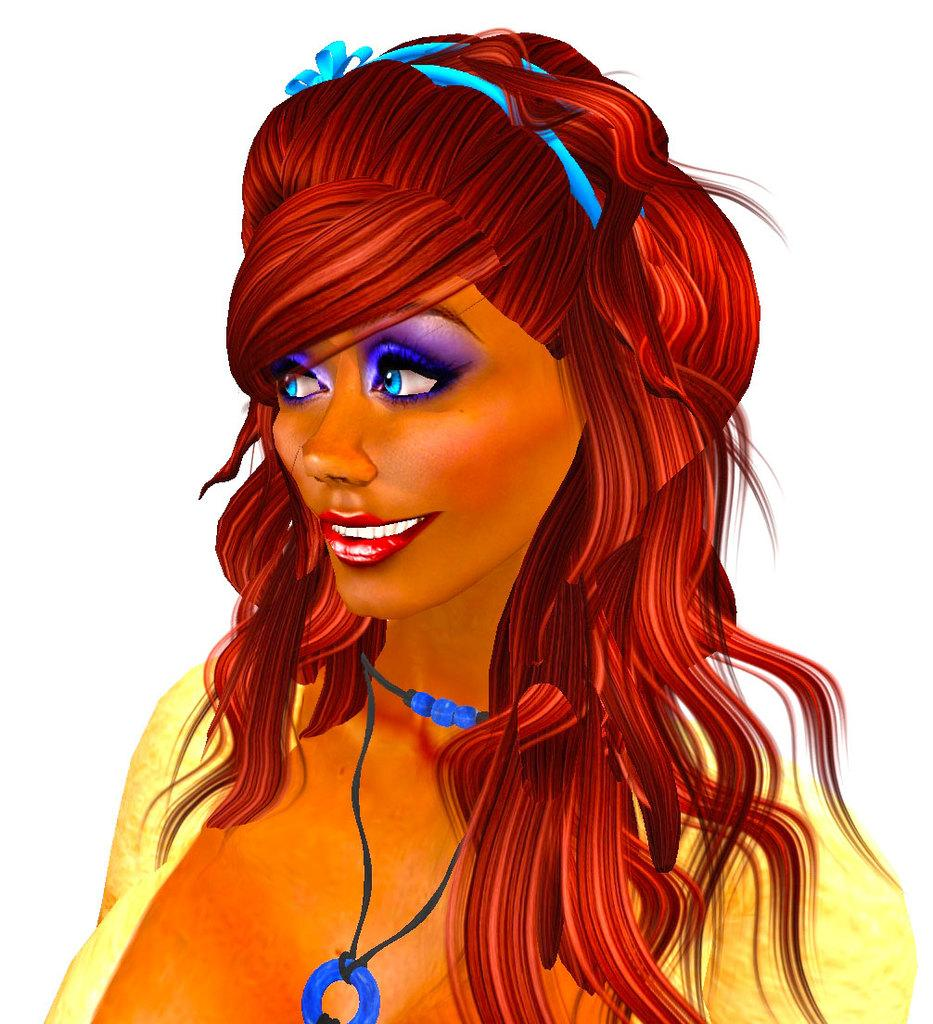What type of image is depicted in the picture? There is a cartoon in the image. Can you describe the main character in the cartoon? The cartoon is a woman. What color is the woman's top in the cartoon? The woman is wearing a yellow top. What accessory is the woman wearing in the cartoon? The woman is wearing a blue necklace. What religion does the woman in the cartoon practice? There is no information about the woman's religion in the image, as it only shows a cartoon of a woman wearing a yellow top and a blue necklace. 